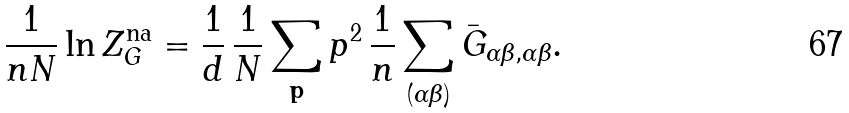<formula> <loc_0><loc_0><loc_500><loc_500>\frac { 1 } { n N } \ln Z _ { G } ^ { \text {na} } = \frac { 1 } { d } \, \frac { 1 } { N } \sum _ { \mathbf p } p ^ { 2 } \, \frac { 1 } { n } \sum _ { ( \alpha \beta ) } \bar { G } _ { \alpha \beta , \alpha \beta } .</formula> 